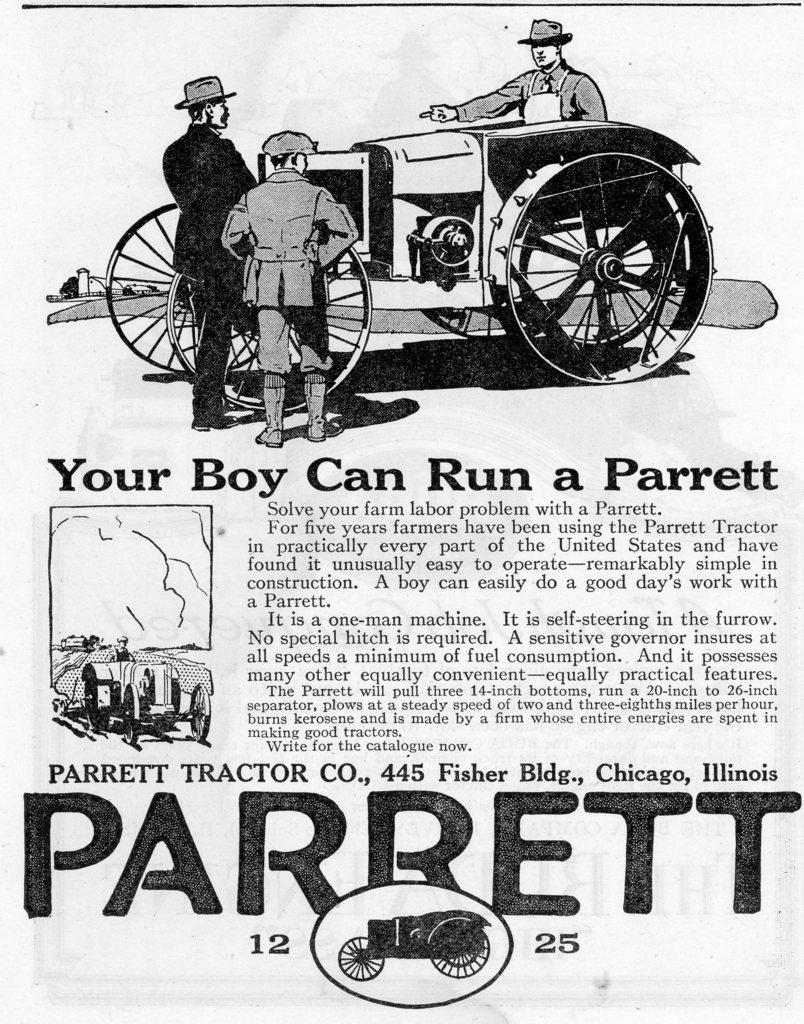What type of content can be found in the image? There is text and numbers in the image. Can you describe the people in the image? There are persons standing and one person sitting in a vehicle in the image. What is the nature of the image? The image is animated and edited. What type of locket is being worn by the person sitting in the vehicle? There is no locket visible in the image, as it only shows text, numbers, and people. What form does the animated content take in the image? The provided facts do not specify the form of the animated content in the image. 